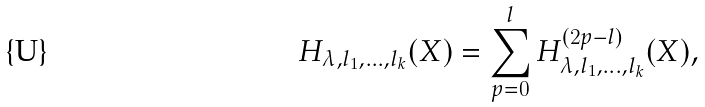Convert formula to latex. <formula><loc_0><loc_0><loc_500><loc_500>H _ { \lambda , l _ { 1 } , \dots , l _ { k } } ( X ) = \sum _ { p = 0 } ^ { l } H _ { \lambda , l _ { 1 } , \dots , l _ { k } } ^ { ( 2 p - l ) } ( X ) ,</formula> 